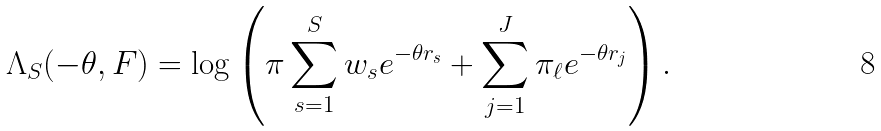<formula> <loc_0><loc_0><loc_500><loc_500>\Lambda _ { S } ( - \theta , F ) = \log \left ( \pi \sum _ { s = 1 } ^ { S } w _ { s } e ^ { - \theta r _ { s } } + \sum _ { j = 1 } ^ { J } \pi _ { \ell } e ^ { - \theta r _ { j } } \right ) .</formula> 